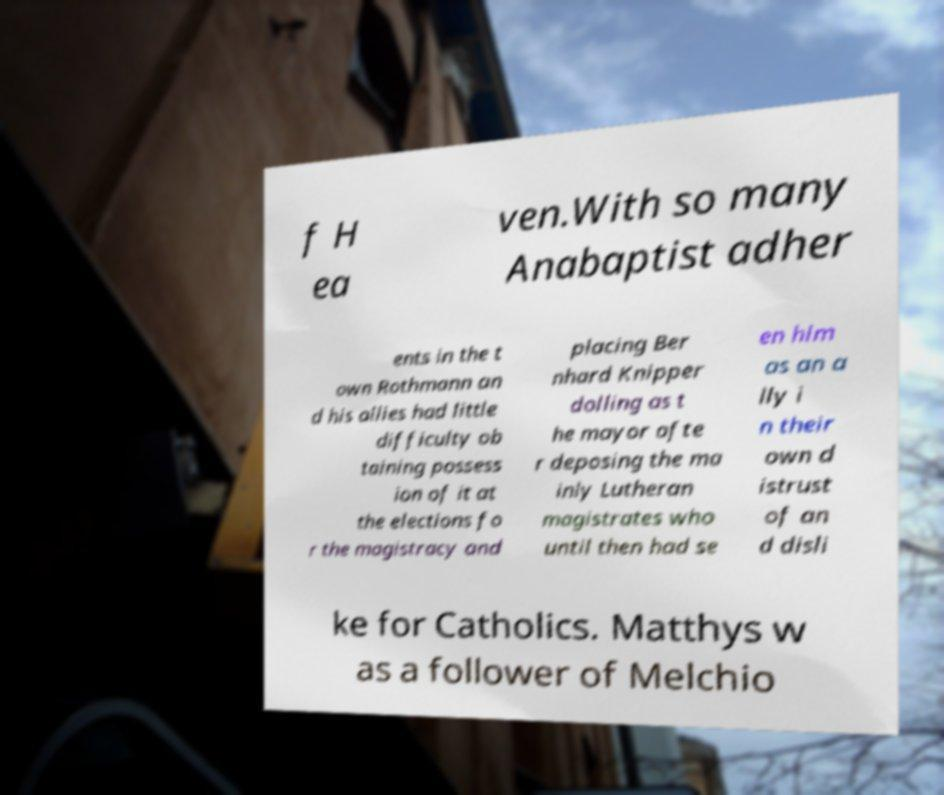Please read and relay the text visible in this image. What does it say? f H ea ven.With so many Anabaptist adher ents in the t own Rothmann an d his allies had little difficulty ob taining possess ion of it at the elections fo r the magistracy and placing Ber nhard Knipper dolling as t he mayor afte r deposing the ma inly Lutheran magistrates who until then had se en him as an a lly i n their own d istrust of an d disli ke for Catholics. Matthys w as a follower of Melchio 